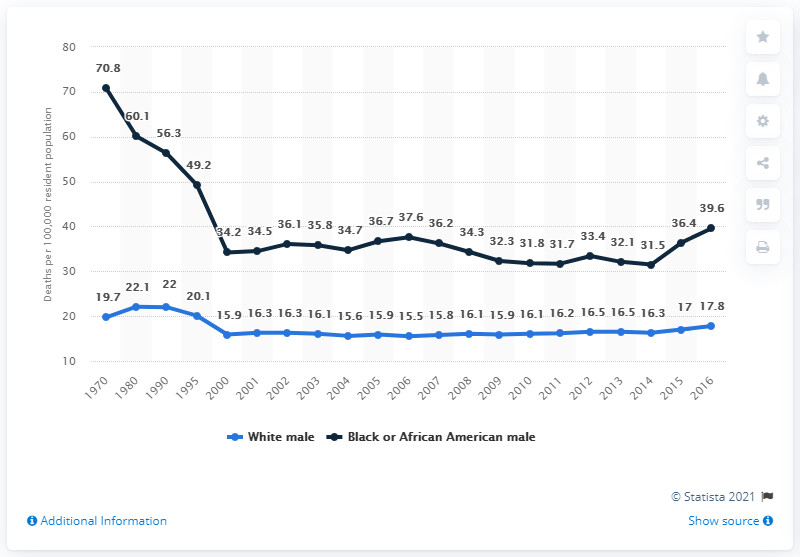Give some essential details in this illustration. In 2016, the percentage of black male deaths per 100,000 population was 39.6%. In 2016, there were 17.8 white male deaths per 100,000 residents in the United States. 